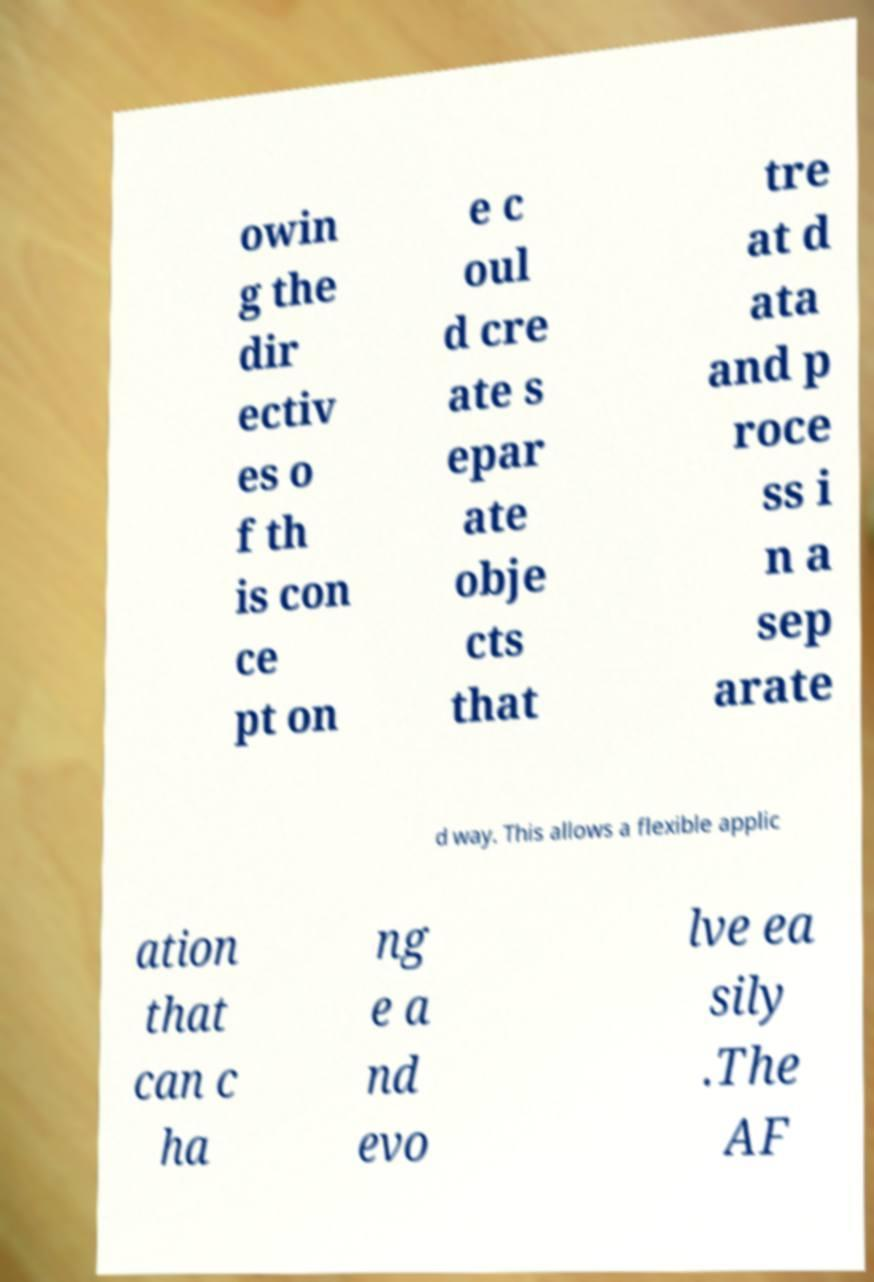Please read and relay the text visible in this image. What does it say? owin g the dir ectiv es o f th is con ce pt on e c oul d cre ate s epar ate obje cts that tre at d ata and p roce ss i n a sep arate d way. This allows a flexible applic ation that can c ha ng e a nd evo lve ea sily .The AF 